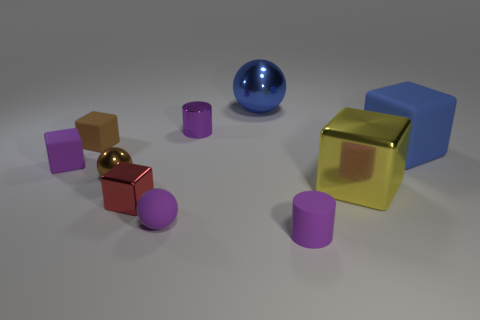There is a sphere that is the same color as the big matte thing; what size is it?
Give a very brief answer. Large. Does the shiny cube that is left of the yellow thing have the same color as the tiny metallic ball?
Offer a terse response. No. There is a purple thing that is the same shape as the big blue rubber thing; what size is it?
Your answer should be very brief. Small. Are there any other things that have the same material as the small red cube?
Make the answer very short. Yes. There is a brown object that is behind the metallic sphere that is in front of the purple cube; are there any purple cylinders that are behind it?
Your answer should be very brief. Yes. There is a small brown object behind the blue cube; what material is it?
Ensure brevity in your answer.  Rubber. What number of tiny things are either blue matte blocks or balls?
Provide a succinct answer. 2. There is a shiny thing that is in front of the yellow metallic thing; is it the same size as the purple matte sphere?
Provide a short and direct response. Yes. How many other objects are there of the same color as the rubber ball?
Provide a short and direct response. 3. What material is the big sphere?
Your answer should be very brief. Metal. 